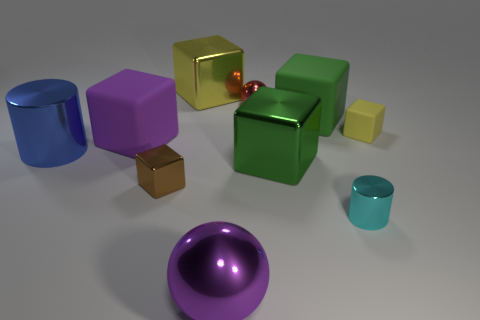Subtract all green cubes. How many cubes are left? 4 Subtract all small rubber blocks. How many blocks are left? 5 Subtract all cyan cubes. Subtract all green balls. How many cubes are left? 6 Subtract all cylinders. How many objects are left? 8 Subtract all small metal cylinders. Subtract all small red metallic things. How many objects are left? 8 Add 3 tiny things. How many tiny things are left? 7 Add 1 small metallic objects. How many small metallic objects exist? 4 Subtract 0 brown cylinders. How many objects are left? 10 